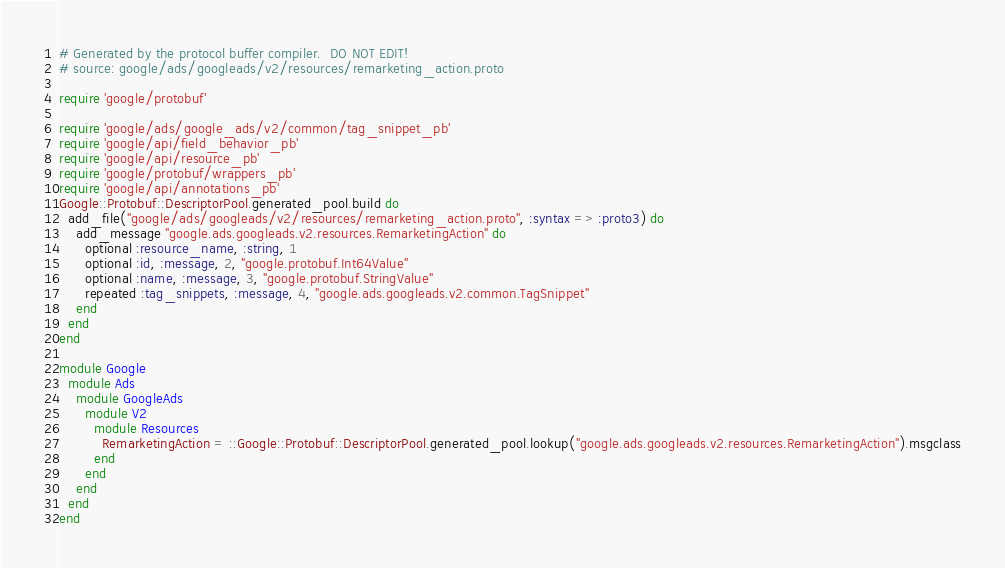Convert code to text. <code><loc_0><loc_0><loc_500><loc_500><_Ruby_># Generated by the protocol buffer compiler.  DO NOT EDIT!
# source: google/ads/googleads/v2/resources/remarketing_action.proto

require 'google/protobuf'

require 'google/ads/google_ads/v2/common/tag_snippet_pb'
require 'google/api/field_behavior_pb'
require 'google/api/resource_pb'
require 'google/protobuf/wrappers_pb'
require 'google/api/annotations_pb'
Google::Protobuf::DescriptorPool.generated_pool.build do
  add_file("google/ads/googleads/v2/resources/remarketing_action.proto", :syntax => :proto3) do
    add_message "google.ads.googleads.v2.resources.RemarketingAction" do
      optional :resource_name, :string, 1
      optional :id, :message, 2, "google.protobuf.Int64Value"
      optional :name, :message, 3, "google.protobuf.StringValue"
      repeated :tag_snippets, :message, 4, "google.ads.googleads.v2.common.TagSnippet"
    end
  end
end

module Google
  module Ads
    module GoogleAds
      module V2
        module Resources
          RemarketingAction = ::Google::Protobuf::DescriptorPool.generated_pool.lookup("google.ads.googleads.v2.resources.RemarketingAction").msgclass
        end
      end
    end
  end
end
</code> 